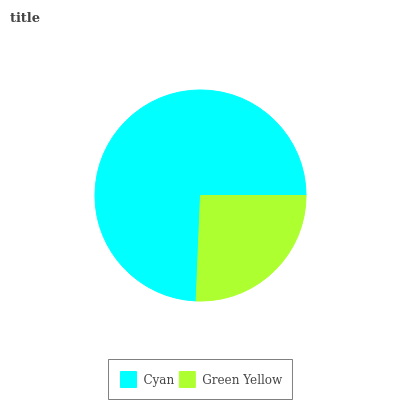Is Green Yellow the minimum?
Answer yes or no. Yes. Is Cyan the maximum?
Answer yes or no. Yes. Is Green Yellow the maximum?
Answer yes or no. No. Is Cyan greater than Green Yellow?
Answer yes or no. Yes. Is Green Yellow less than Cyan?
Answer yes or no. Yes. Is Green Yellow greater than Cyan?
Answer yes or no. No. Is Cyan less than Green Yellow?
Answer yes or no. No. Is Cyan the high median?
Answer yes or no. Yes. Is Green Yellow the low median?
Answer yes or no. Yes. Is Green Yellow the high median?
Answer yes or no. No. Is Cyan the low median?
Answer yes or no. No. 